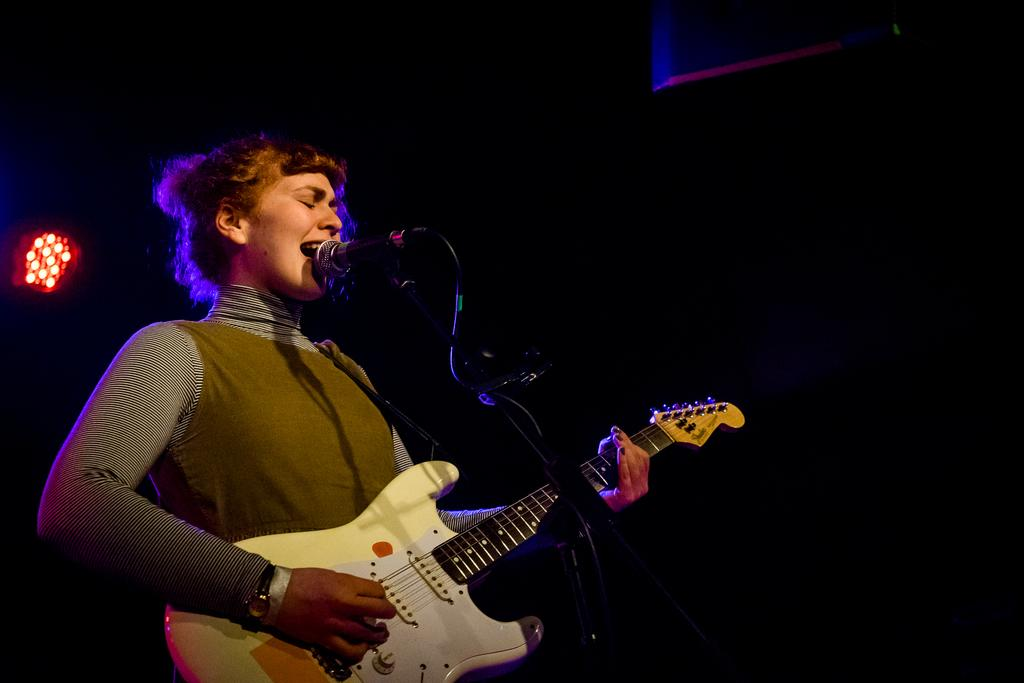Who is the main subject in the image? There is a girl in the image. What is the girl doing in the image? The girl is playing a guitar. What other object is present in the image related to music? There is a microphone in the image. What can be seen in the background of the image? There is light visible in the background. How many nuts are on the girl's head in the image? There are no nuts present on the girl's head in the image. Can you tell me the color of the duck in the image? There is no duck present in the image. 